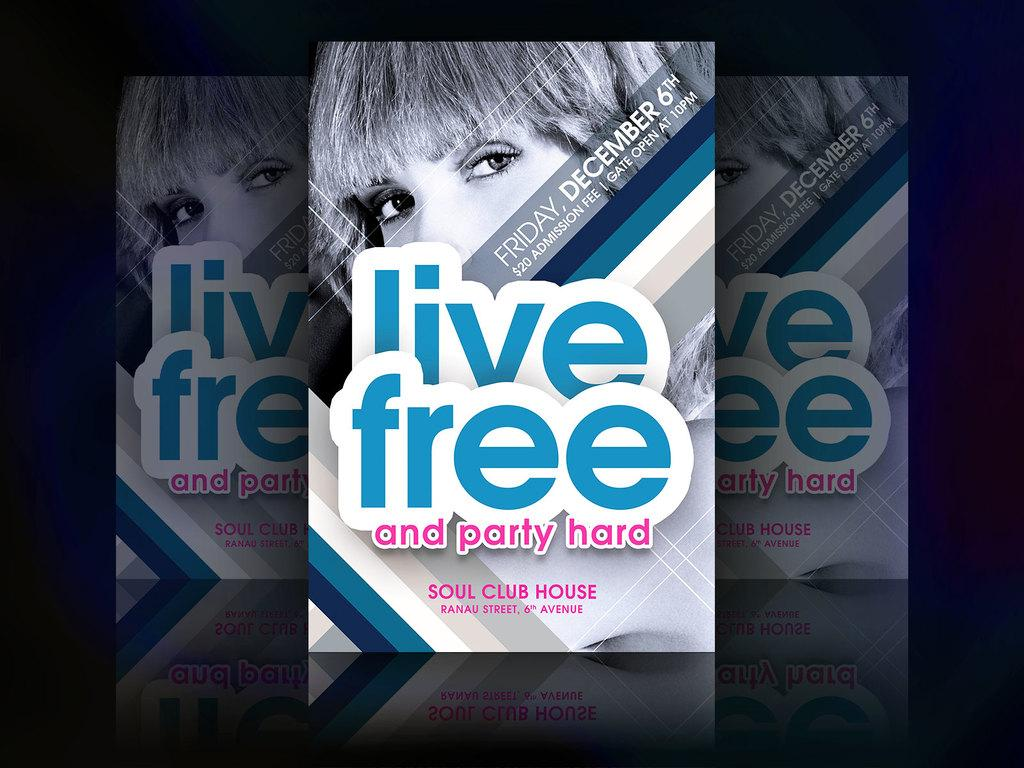<image>
Offer a succinct explanation of the picture presented. A women with short hair displayed on a Live Free and party hard pamphlet 